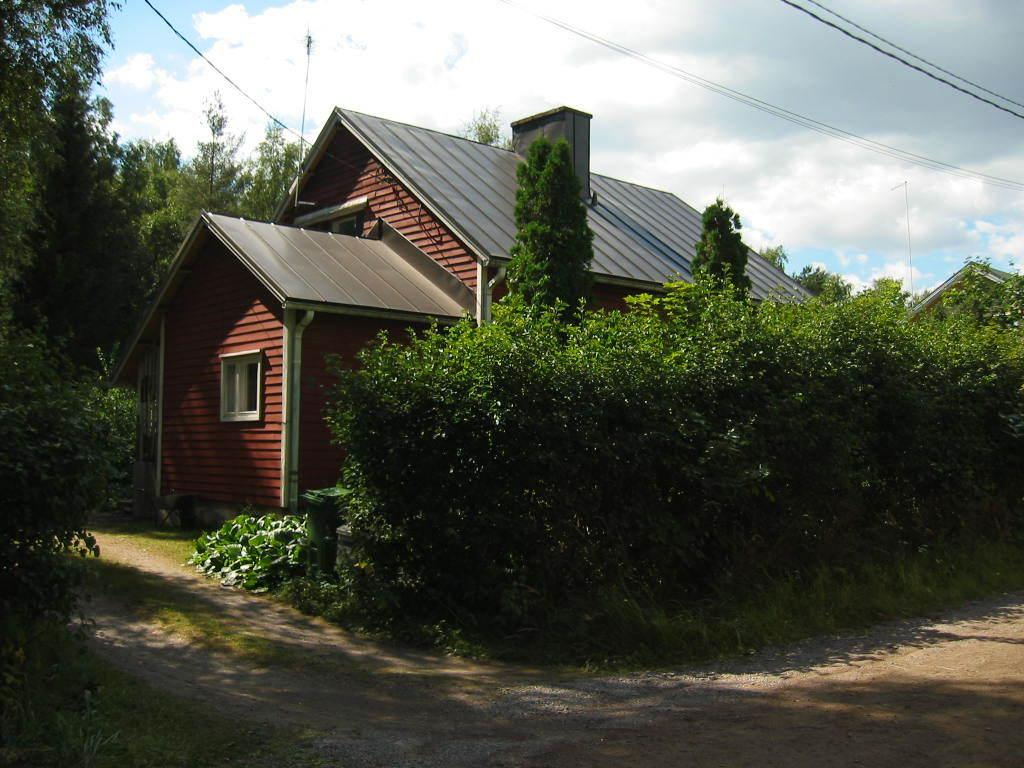What type of vegetation can be seen in the image? There are trees in the image. What structure is visible in the background of the image? There is a house in the background of the image. What is visible at the top of the image? The sky is visible in the image. What else can be seen at the top of the image? There are wires at the top of the image. What mark can be seen on the trees in the image? There is no mark on the trees in the image; only the trees themselves are visible. What song is being sung by the trees in the image? Trees do not sing songs, so there is no song being sung by the trees in the image. 